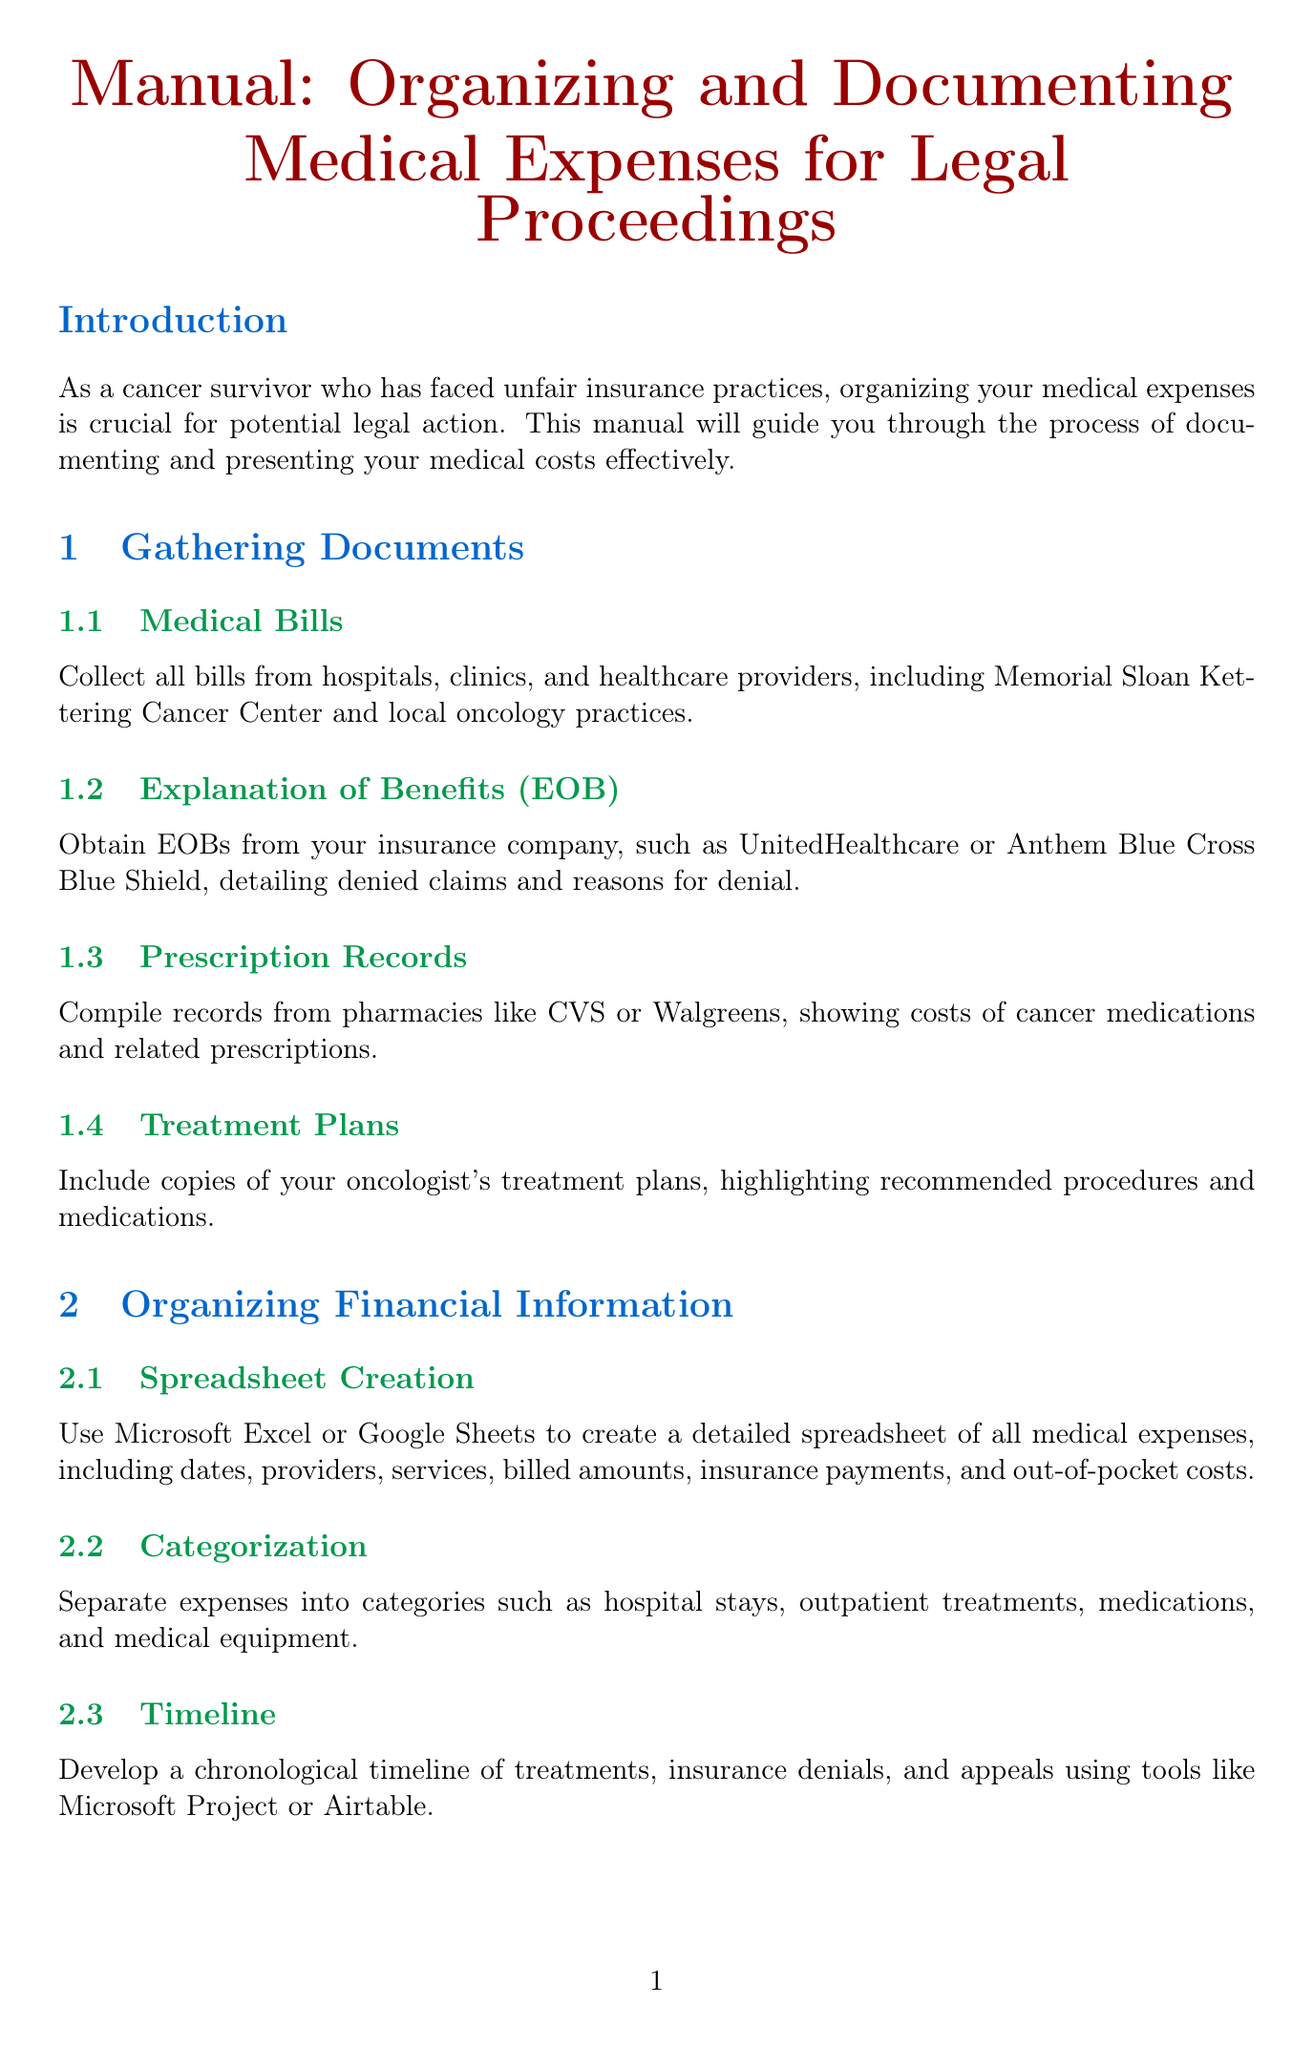What is the title of the manual? The title of the manual is clearly stated at the beginning of the document.
Answer: Manual: Organizing and Documenting Medical Expenses for Legal Proceedings Who should maintain a correspondence log? The document suggests that patients should maintain logs of their communications with their insurance company.
Answer: Patients What should be included in the personal statement? The manual specifies that the personal statement should cover the individual’s cancer journey and insurance impact.
Answer: Cancer journey and impact of insurance denials What is the purpose of compiling financial impact analysis? The purpose is to detail the financial burden caused by insurance denials.
Answer: To detail the financial burden Which tools are suggested for developing a treatment timeline? The document recommends specific tools for creating a chronological timeline.
Answer: Microsoft Project or Airtable What type of statements should be included from medical professionals? The manual states that expert opinions from oncologists or medical professionals should be included.
Answer: Expert opinions What kind of letters should be organized regarding denials? The document indicates that denial letters received from insurance providers should be organized.
Answer: Denial letters What organization could you consult for legal representation? The manual mentions specific organizations that specialize in insurance denials.
Answer: Patient Advocate Foundation or Cancer Legal Resource Center 